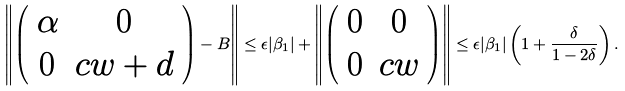Convert formula to latex. <formula><loc_0><loc_0><loc_500><loc_500>\left \| \left ( \begin{array} { c c } \alpha & 0 \\ 0 & c w + d \end{array} \right ) - B \right \| \leq \epsilon | \beta _ { 1 } | + \left \| \left ( \begin{array} { c c } 0 & 0 \\ 0 & c w \end{array} \right ) \right \| \leq \epsilon | \beta _ { 1 } | \left ( 1 + \frac { \delta } { 1 - 2 \delta } \right ) .</formula> 